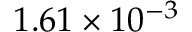Convert formula to latex. <formula><loc_0><loc_0><loc_500><loc_500>1 . 6 1 \times 1 0 ^ { - 3 }</formula> 